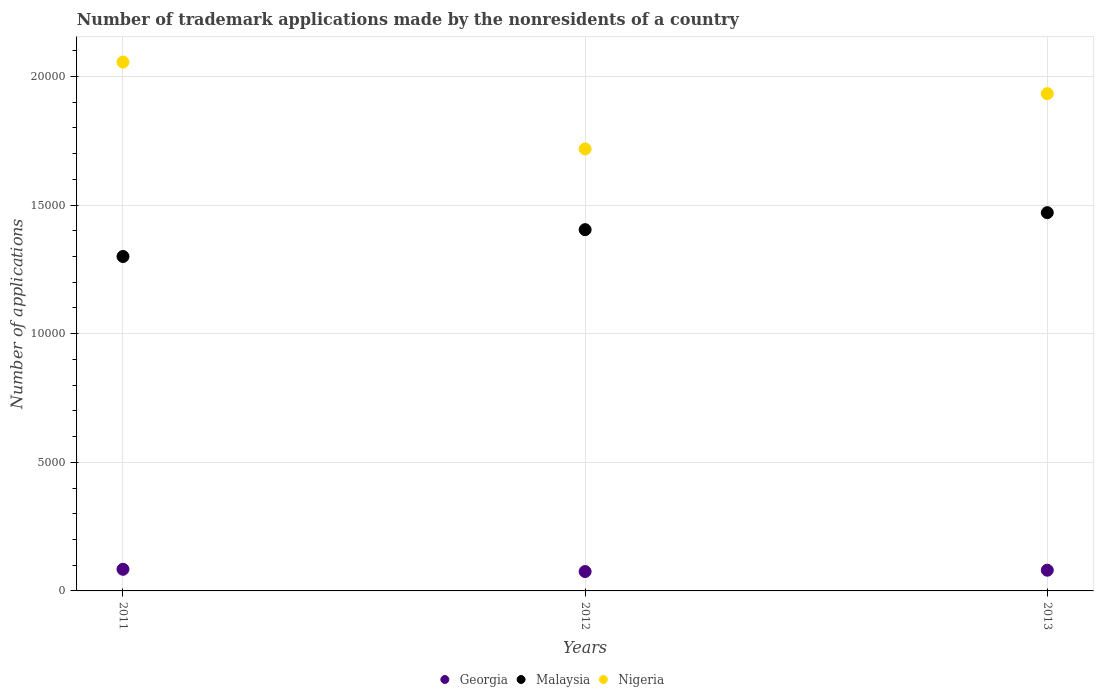What is the number of trademark applications made by the nonresidents in Nigeria in 2011?
Keep it short and to the point. 2.06e+04. Across all years, what is the maximum number of trademark applications made by the nonresidents in Georgia?
Give a very brief answer. 841. Across all years, what is the minimum number of trademark applications made by the nonresidents in Nigeria?
Keep it short and to the point. 1.72e+04. In which year was the number of trademark applications made by the nonresidents in Georgia minimum?
Your response must be concise. 2012. What is the total number of trademark applications made by the nonresidents in Georgia in the graph?
Keep it short and to the point. 2399. What is the difference between the number of trademark applications made by the nonresidents in Malaysia in 2011 and that in 2013?
Your answer should be very brief. -1704. What is the difference between the number of trademark applications made by the nonresidents in Malaysia in 2013 and the number of trademark applications made by the nonresidents in Nigeria in 2012?
Offer a terse response. -2477. What is the average number of trademark applications made by the nonresidents in Nigeria per year?
Offer a very short reply. 1.90e+04. In the year 2012, what is the difference between the number of trademark applications made by the nonresidents in Nigeria and number of trademark applications made by the nonresidents in Georgia?
Provide a succinct answer. 1.64e+04. What is the ratio of the number of trademark applications made by the nonresidents in Malaysia in 2012 to that in 2013?
Keep it short and to the point. 0.96. Is the number of trademark applications made by the nonresidents in Georgia in 2011 less than that in 2013?
Your answer should be compact. No. Is the difference between the number of trademark applications made by the nonresidents in Nigeria in 2011 and 2013 greater than the difference between the number of trademark applications made by the nonresidents in Georgia in 2011 and 2013?
Ensure brevity in your answer.  Yes. In how many years, is the number of trademark applications made by the nonresidents in Nigeria greater than the average number of trademark applications made by the nonresidents in Nigeria taken over all years?
Offer a very short reply. 2. How many dotlines are there?
Give a very brief answer. 3. How many years are there in the graph?
Give a very brief answer. 3. Does the graph contain any zero values?
Offer a very short reply. No. Does the graph contain grids?
Keep it short and to the point. Yes. How many legend labels are there?
Give a very brief answer. 3. How are the legend labels stacked?
Offer a terse response. Horizontal. What is the title of the graph?
Your answer should be very brief. Number of trademark applications made by the nonresidents of a country. What is the label or title of the X-axis?
Your answer should be very brief. Years. What is the label or title of the Y-axis?
Provide a succinct answer. Number of applications. What is the Number of applications of Georgia in 2011?
Offer a terse response. 841. What is the Number of applications in Malaysia in 2011?
Offer a terse response. 1.30e+04. What is the Number of applications in Nigeria in 2011?
Provide a succinct answer. 2.06e+04. What is the Number of applications of Georgia in 2012?
Keep it short and to the point. 753. What is the Number of applications in Malaysia in 2012?
Your answer should be compact. 1.40e+04. What is the Number of applications in Nigeria in 2012?
Provide a short and direct response. 1.72e+04. What is the Number of applications of Georgia in 2013?
Offer a terse response. 805. What is the Number of applications in Malaysia in 2013?
Provide a short and direct response. 1.47e+04. What is the Number of applications of Nigeria in 2013?
Ensure brevity in your answer.  1.93e+04. Across all years, what is the maximum Number of applications of Georgia?
Your answer should be very brief. 841. Across all years, what is the maximum Number of applications of Malaysia?
Offer a terse response. 1.47e+04. Across all years, what is the maximum Number of applications in Nigeria?
Offer a very short reply. 2.06e+04. Across all years, what is the minimum Number of applications in Georgia?
Your response must be concise. 753. Across all years, what is the minimum Number of applications in Malaysia?
Offer a very short reply. 1.30e+04. Across all years, what is the minimum Number of applications in Nigeria?
Your answer should be compact. 1.72e+04. What is the total Number of applications of Georgia in the graph?
Make the answer very short. 2399. What is the total Number of applications of Malaysia in the graph?
Provide a short and direct response. 4.18e+04. What is the total Number of applications of Nigeria in the graph?
Your answer should be compact. 5.71e+04. What is the difference between the Number of applications in Malaysia in 2011 and that in 2012?
Your answer should be compact. -1043. What is the difference between the Number of applications in Nigeria in 2011 and that in 2012?
Ensure brevity in your answer.  3378. What is the difference between the Number of applications of Malaysia in 2011 and that in 2013?
Your response must be concise. -1704. What is the difference between the Number of applications of Nigeria in 2011 and that in 2013?
Keep it short and to the point. 1228. What is the difference between the Number of applications of Georgia in 2012 and that in 2013?
Provide a succinct answer. -52. What is the difference between the Number of applications of Malaysia in 2012 and that in 2013?
Your answer should be compact. -661. What is the difference between the Number of applications in Nigeria in 2012 and that in 2013?
Give a very brief answer. -2150. What is the difference between the Number of applications of Georgia in 2011 and the Number of applications of Malaysia in 2012?
Make the answer very short. -1.32e+04. What is the difference between the Number of applications of Georgia in 2011 and the Number of applications of Nigeria in 2012?
Your answer should be very brief. -1.63e+04. What is the difference between the Number of applications of Malaysia in 2011 and the Number of applications of Nigeria in 2012?
Your response must be concise. -4181. What is the difference between the Number of applications in Georgia in 2011 and the Number of applications in Malaysia in 2013?
Make the answer very short. -1.39e+04. What is the difference between the Number of applications in Georgia in 2011 and the Number of applications in Nigeria in 2013?
Offer a terse response. -1.85e+04. What is the difference between the Number of applications in Malaysia in 2011 and the Number of applications in Nigeria in 2013?
Your answer should be compact. -6331. What is the difference between the Number of applications of Georgia in 2012 and the Number of applications of Malaysia in 2013?
Make the answer very short. -1.40e+04. What is the difference between the Number of applications of Georgia in 2012 and the Number of applications of Nigeria in 2013?
Offer a very short reply. -1.86e+04. What is the difference between the Number of applications of Malaysia in 2012 and the Number of applications of Nigeria in 2013?
Make the answer very short. -5288. What is the average Number of applications of Georgia per year?
Provide a succinct answer. 799.67. What is the average Number of applications in Malaysia per year?
Your response must be concise. 1.39e+04. What is the average Number of applications in Nigeria per year?
Provide a short and direct response. 1.90e+04. In the year 2011, what is the difference between the Number of applications in Georgia and Number of applications in Malaysia?
Offer a very short reply. -1.22e+04. In the year 2011, what is the difference between the Number of applications of Georgia and Number of applications of Nigeria?
Offer a terse response. -1.97e+04. In the year 2011, what is the difference between the Number of applications of Malaysia and Number of applications of Nigeria?
Give a very brief answer. -7559. In the year 2012, what is the difference between the Number of applications of Georgia and Number of applications of Malaysia?
Give a very brief answer. -1.33e+04. In the year 2012, what is the difference between the Number of applications of Georgia and Number of applications of Nigeria?
Provide a succinct answer. -1.64e+04. In the year 2012, what is the difference between the Number of applications of Malaysia and Number of applications of Nigeria?
Make the answer very short. -3138. In the year 2013, what is the difference between the Number of applications of Georgia and Number of applications of Malaysia?
Your response must be concise. -1.39e+04. In the year 2013, what is the difference between the Number of applications in Georgia and Number of applications in Nigeria?
Give a very brief answer. -1.85e+04. In the year 2013, what is the difference between the Number of applications of Malaysia and Number of applications of Nigeria?
Give a very brief answer. -4627. What is the ratio of the Number of applications in Georgia in 2011 to that in 2012?
Your answer should be very brief. 1.12. What is the ratio of the Number of applications of Malaysia in 2011 to that in 2012?
Offer a terse response. 0.93. What is the ratio of the Number of applications in Nigeria in 2011 to that in 2012?
Provide a short and direct response. 1.2. What is the ratio of the Number of applications in Georgia in 2011 to that in 2013?
Provide a short and direct response. 1.04. What is the ratio of the Number of applications in Malaysia in 2011 to that in 2013?
Your answer should be compact. 0.88. What is the ratio of the Number of applications of Nigeria in 2011 to that in 2013?
Your answer should be compact. 1.06. What is the ratio of the Number of applications of Georgia in 2012 to that in 2013?
Provide a succinct answer. 0.94. What is the ratio of the Number of applications of Malaysia in 2012 to that in 2013?
Provide a short and direct response. 0.95. What is the ratio of the Number of applications in Nigeria in 2012 to that in 2013?
Offer a terse response. 0.89. What is the difference between the highest and the second highest Number of applications in Malaysia?
Provide a short and direct response. 661. What is the difference between the highest and the second highest Number of applications of Nigeria?
Give a very brief answer. 1228. What is the difference between the highest and the lowest Number of applications of Georgia?
Provide a short and direct response. 88. What is the difference between the highest and the lowest Number of applications in Malaysia?
Give a very brief answer. 1704. What is the difference between the highest and the lowest Number of applications of Nigeria?
Offer a very short reply. 3378. 